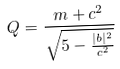Convert formula to latex. <formula><loc_0><loc_0><loc_500><loc_500>Q = \frac { m + c ^ { 2 } } { \sqrt { 5 - \frac { | b | ^ { 2 } } { c ^ { 2 } } } }</formula> 